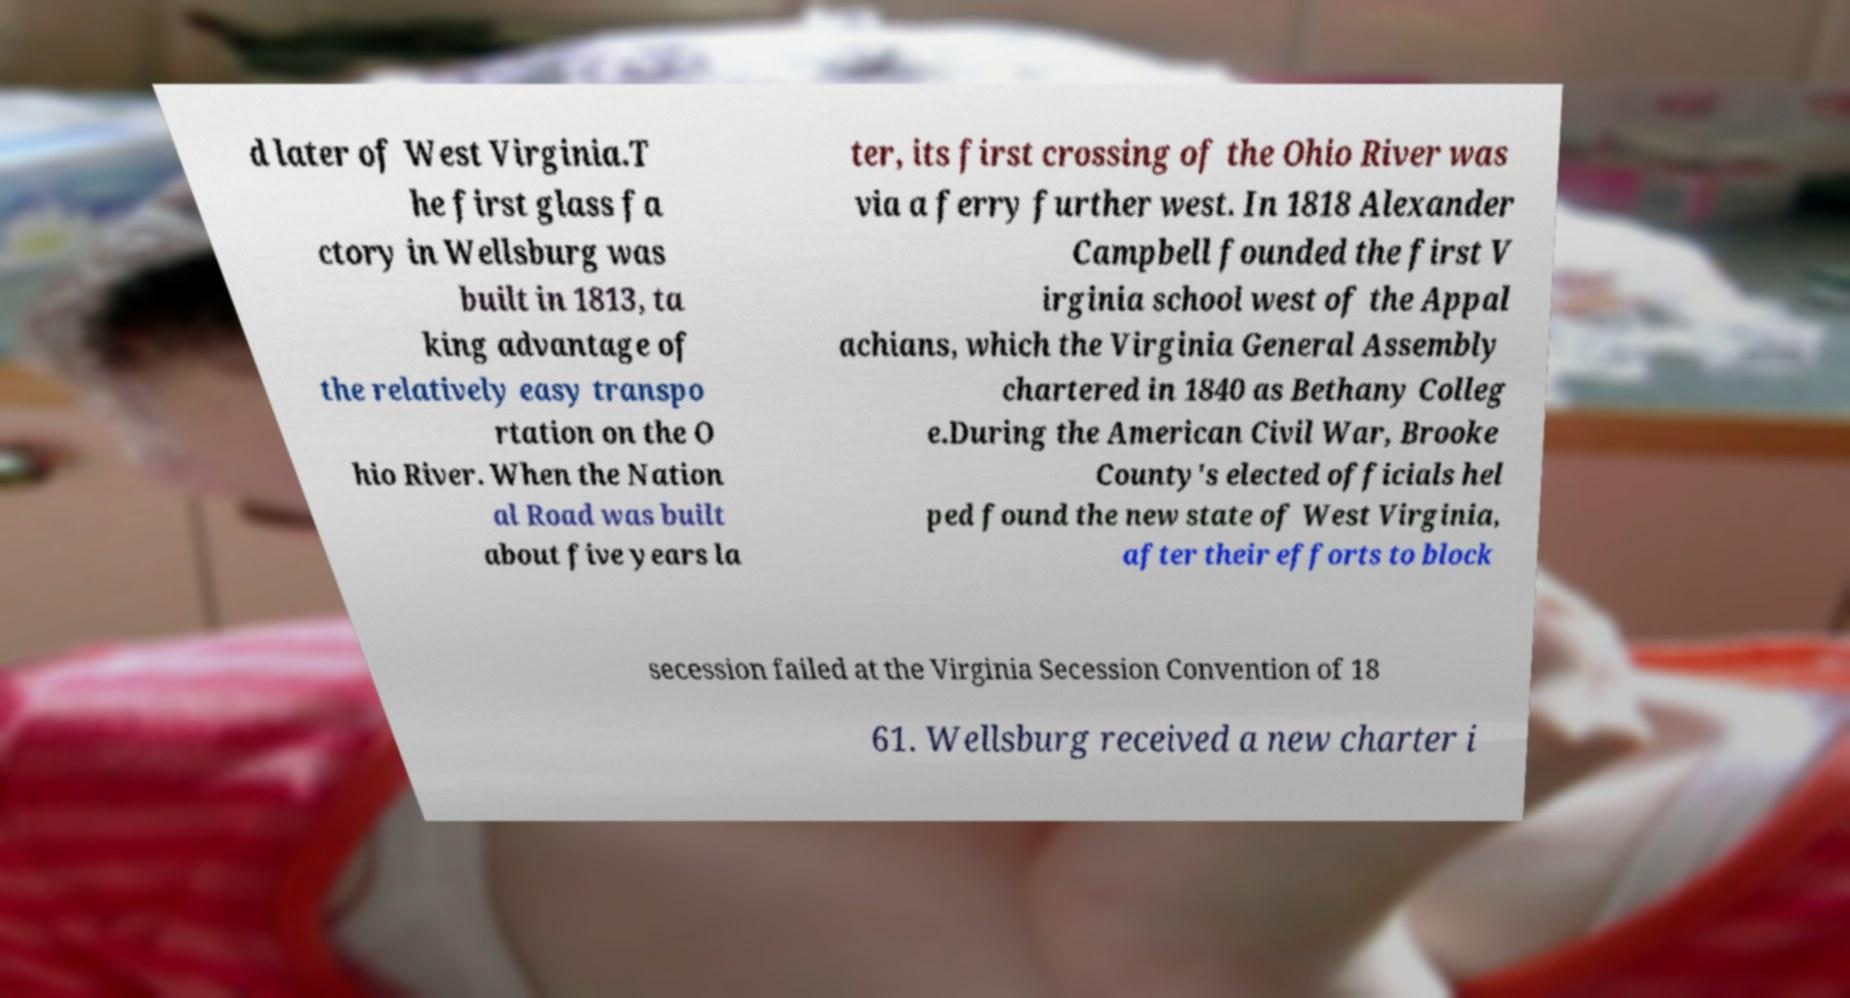Can you accurately transcribe the text from the provided image for me? d later of West Virginia.T he first glass fa ctory in Wellsburg was built in 1813, ta king advantage of the relatively easy transpo rtation on the O hio River. When the Nation al Road was built about five years la ter, its first crossing of the Ohio River was via a ferry further west. In 1818 Alexander Campbell founded the first V irginia school west of the Appal achians, which the Virginia General Assembly chartered in 1840 as Bethany Colleg e.During the American Civil War, Brooke County's elected officials hel ped found the new state of West Virginia, after their efforts to block secession failed at the Virginia Secession Convention of 18 61. Wellsburg received a new charter i 